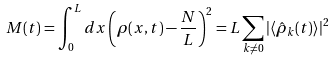<formula> <loc_0><loc_0><loc_500><loc_500>M ( t ) = \int _ { 0 } ^ { L } d x \left ( \rho ( x , t ) - \frac { N } { L } \right ) ^ { 2 } = L \sum _ { k \ne 0 } | \langle { \hat { \rho } } _ { k } ( t ) \rangle | ^ { 2 }</formula> 